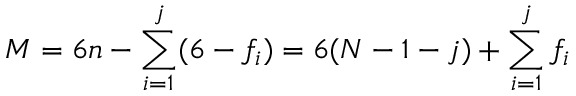Convert formula to latex. <formula><loc_0><loc_0><loc_500><loc_500>M = 6 n - \sum _ { i = 1 } ^ { j } ( 6 - f _ { i } ) = 6 ( N - 1 - j ) + \sum _ { i = 1 } ^ { j } f _ { i }</formula> 